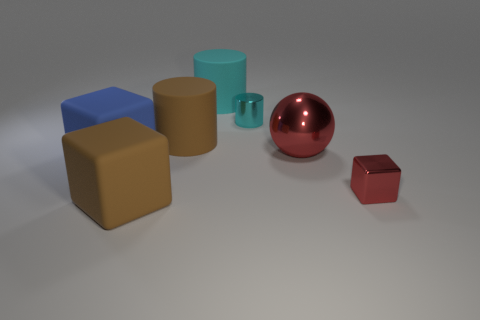Is there anything else that has the same shape as the big red object?
Keep it short and to the point. No. Is the number of big cyan cylinders greater than the number of large brown objects?
Offer a very short reply. No. There is a brown object that is the same shape as the cyan shiny thing; what is its material?
Make the answer very short. Rubber. Does the blue thing have the same material as the brown cylinder?
Offer a terse response. Yes. Is the number of rubber blocks on the right side of the big brown cylinder greater than the number of metal spheres?
Offer a terse response. No. There is a red thing behind the block that is on the right side of the brown matte thing in front of the large red metallic object; what is it made of?
Your answer should be compact. Metal. How many things are large yellow rubber balls or large rubber cylinders behind the small cyan object?
Ensure brevity in your answer.  1. There is a small metallic thing that is in front of the big blue cube; is it the same color as the large metallic object?
Your response must be concise. Yes. Is the number of red metallic things that are right of the large red metallic sphere greater than the number of tiny red metallic cubes that are in front of the small red thing?
Your answer should be very brief. Yes. Are there any other things of the same color as the sphere?
Keep it short and to the point. Yes. 